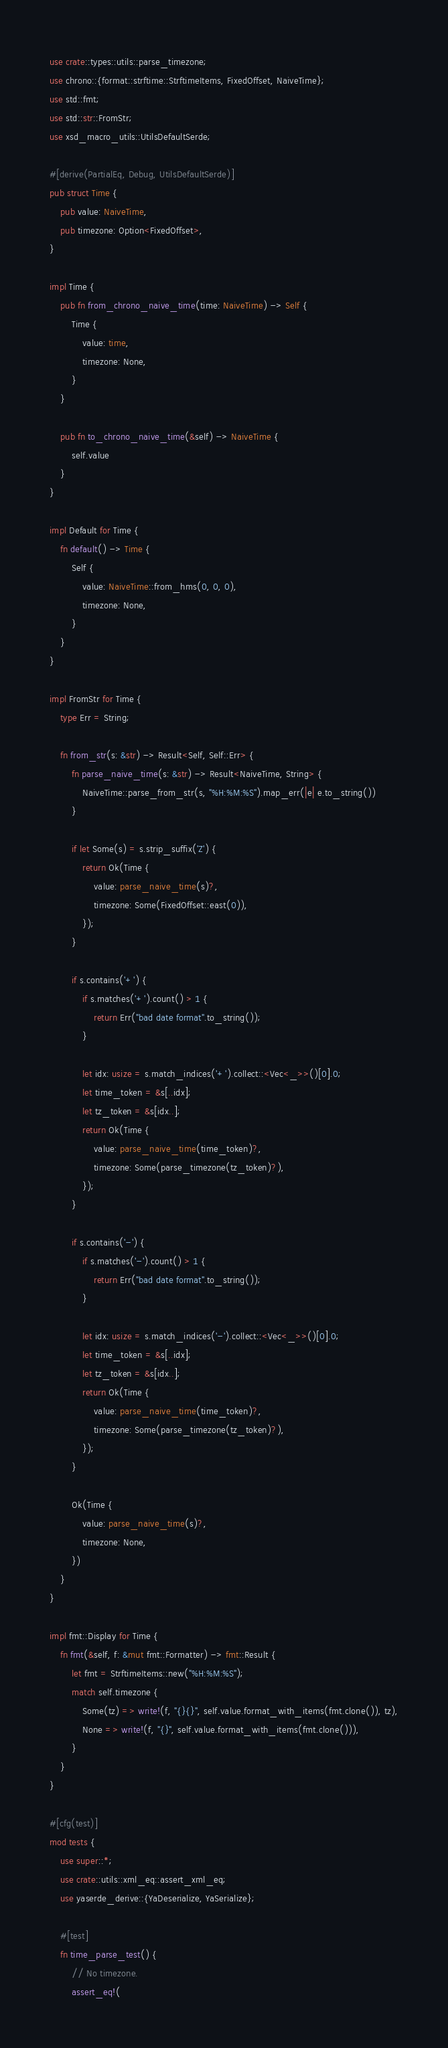<code> <loc_0><loc_0><loc_500><loc_500><_Rust_>use crate::types::utils::parse_timezone;
use chrono::{format::strftime::StrftimeItems, FixedOffset, NaiveTime};
use std::fmt;
use std::str::FromStr;
use xsd_macro_utils::UtilsDefaultSerde;

#[derive(PartialEq, Debug, UtilsDefaultSerde)]
pub struct Time {
    pub value: NaiveTime,
    pub timezone: Option<FixedOffset>,
}

impl Time {
    pub fn from_chrono_naive_time(time: NaiveTime) -> Self {
        Time {
            value: time,
            timezone: None,
        }
    }

    pub fn to_chrono_naive_time(&self) -> NaiveTime {
        self.value
    }
}

impl Default for Time {
    fn default() -> Time {
        Self {
            value: NaiveTime::from_hms(0, 0, 0),
            timezone: None,
        }
    }
}

impl FromStr for Time {
    type Err = String;

    fn from_str(s: &str) -> Result<Self, Self::Err> {
        fn parse_naive_time(s: &str) -> Result<NaiveTime, String> {
            NaiveTime::parse_from_str(s, "%H:%M:%S").map_err(|e| e.to_string())
        }

        if let Some(s) = s.strip_suffix('Z') {
            return Ok(Time {
                value: parse_naive_time(s)?,
                timezone: Some(FixedOffset::east(0)),
            });
        }

        if s.contains('+') {
            if s.matches('+').count() > 1 {
                return Err("bad date format".to_string());
            }

            let idx: usize = s.match_indices('+').collect::<Vec<_>>()[0].0;
            let time_token = &s[..idx];
            let tz_token = &s[idx..];
            return Ok(Time {
                value: parse_naive_time(time_token)?,
                timezone: Some(parse_timezone(tz_token)?),
            });
        }

        if s.contains('-') {
            if s.matches('-').count() > 1 {
                return Err("bad date format".to_string());
            }

            let idx: usize = s.match_indices('-').collect::<Vec<_>>()[0].0;
            let time_token = &s[..idx];
            let tz_token = &s[idx..];
            return Ok(Time {
                value: parse_naive_time(time_token)?,
                timezone: Some(parse_timezone(tz_token)?),
            });
        }

        Ok(Time {
            value: parse_naive_time(s)?,
            timezone: None,
        })
    }
}

impl fmt::Display for Time {
    fn fmt(&self, f: &mut fmt::Formatter) -> fmt::Result {
        let fmt = StrftimeItems::new("%H:%M:%S");
        match self.timezone {
            Some(tz) => write!(f, "{}{}", self.value.format_with_items(fmt.clone()), tz),
            None => write!(f, "{}", self.value.format_with_items(fmt.clone())),
        }
    }
}

#[cfg(test)]
mod tests {
    use super::*;
    use crate::utils::xml_eq::assert_xml_eq;
    use yaserde_derive::{YaDeserialize, YaSerialize};

    #[test]
    fn time_parse_test() {
        // No timezone.
        assert_eq!(</code> 